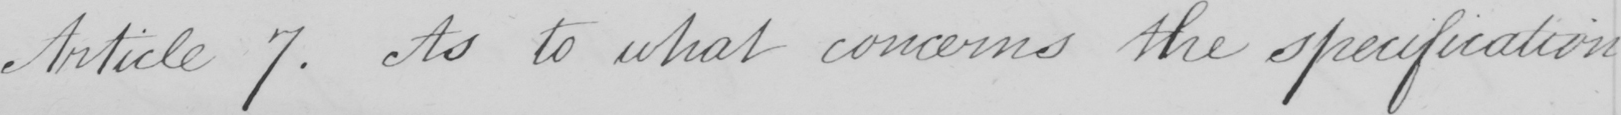Can you tell me what this handwritten text says? Article 7 . As to what concerns the specification 